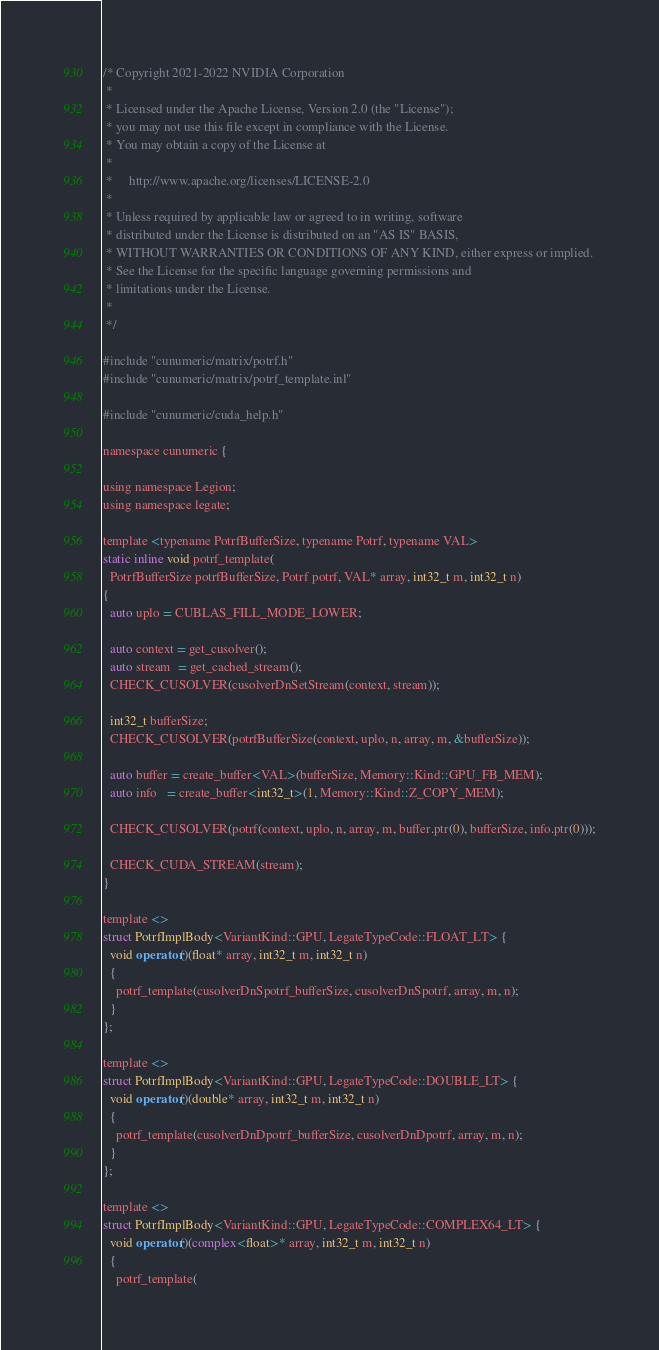<code> <loc_0><loc_0><loc_500><loc_500><_Cuda_>/* Copyright 2021-2022 NVIDIA Corporation
 *
 * Licensed under the Apache License, Version 2.0 (the "License");
 * you may not use this file except in compliance with the License.
 * You may obtain a copy of the License at
 *
 *     http://www.apache.org/licenses/LICENSE-2.0
 *
 * Unless required by applicable law or agreed to in writing, software
 * distributed under the License is distributed on an "AS IS" BASIS,
 * WITHOUT WARRANTIES OR CONDITIONS OF ANY KIND, either express or implied.
 * See the License for the specific language governing permissions and
 * limitations under the License.
 *
 */

#include "cunumeric/matrix/potrf.h"
#include "cunumeric/matrix/potrf_template.inl"

#include "cunumeric/cuda_help.h"

namespace cunumeric {

using namespace Legion;
using namespace legate;

template <typename PotrfBufferSize, typename Potrf, typename VAL>
static inline void potrf_template(
  PotrfBufferSize potrfBufferSize, Potrf potrf, VAL* array, int32_t m, int32_t n)
{
  auto uplo = CUBLAS_FILL_MODE_LOWER;

  auto context = get_cusolver();
  auto stream  = get_cached_stream();
  CHECK_CUSOLVER(cusolverDnSetStream(context, stream));

  int32_t bufferSize;
  CHECK_CUSOLVER(potrfBufferSize(context, uplo, n, array, m, &bufferSize));

  auto buffer = create_buffer<VAL>(bufferSize, Memory::Kind::GPU_FB_MEM);
  auto info   = create_buffer<int32_t>(1, Memory::Kind::Z_COPY_MEM);

  CHECK_CUSOLVER(potrf(context, uplo, n, array, m, buffer.ptr(0), bufferSize, info.ptr(0)));

  CHECK_CUDA_STREAM(stream);
}

template <>
struct PotrfImplBody<VariantKind::GPU, LegateTypeCode::FLOAT_LT> {
  void operator()(float* array, int32_t m, int32_t n)
  {
    potrf_template(cusolverDnSpotrf_bufferSize, cusolverDnSpotrf, array, m, n);
  }
};

template <>
struct PotrfImplBody<VariantKind::GPU, LegateTypeCode::DOUBLE_LT> {
  void operator()(double* array, int32_t m, int32_t n)
  {
    potrf_template(cusolverDnDpotrf_bufferSize, cusolverDnDpotrf, array, m, n);
  }
};

template <>
struct PotrfImplBody<VariantKind::GPU, LegateTypeCode::COMPLEX64_LT> {
  void operator()(complex<float>* array, int32_t m, int32_t n)
  {
    potrf_template(</code> 